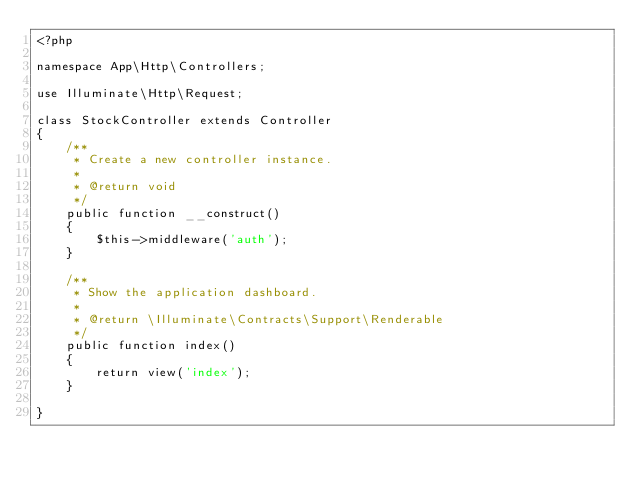Convert code to text. <code><loc_0><loc_0><loc_500><loc_500><_PHP_><?php

namespace App\Http\Controllers;

use Illuminate\Http\Request;

class StockController extends Controller
{
    /**
     * Create a new controller instance.
     *
     * @return void
     */
    public function __construct()
    {
        $this->middleware('auth');
    }

    /**
     * Show the application dashboard.
     *
     * @return \Illuminate\Contracts\Support\Renderable
     */
    public function index()
    {
        return view('index');
    }

}
</code> 